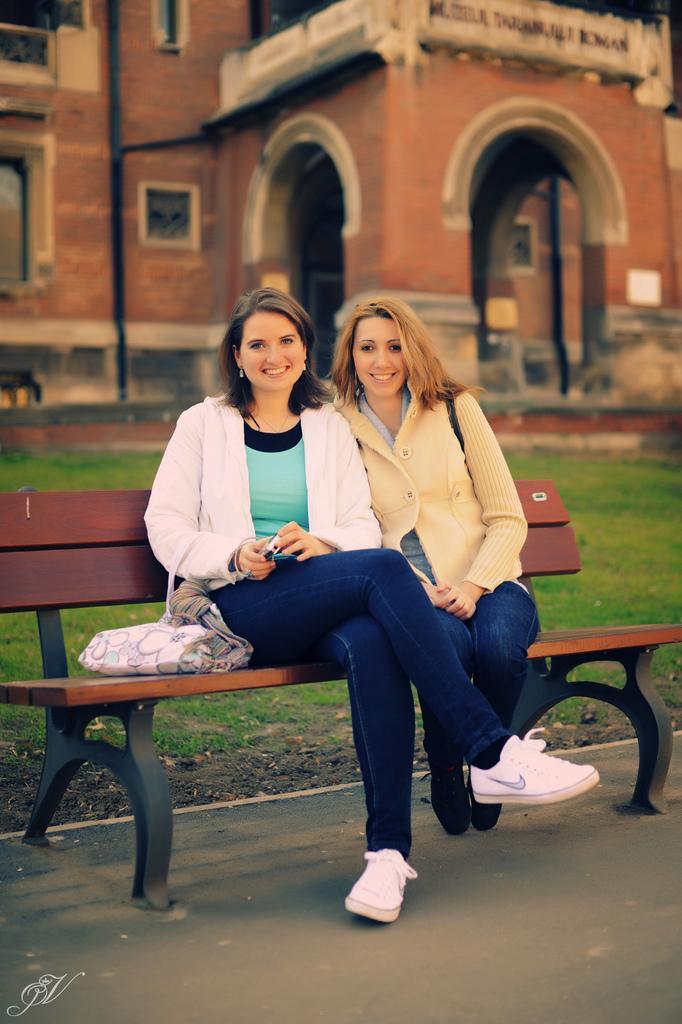Can you describe this image briefly? In this picture there are two women seated on a bench wearing hoodies. In the foreground there is a road. On the background there is a building. In the center of the picture there is grass. 